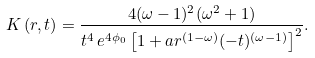<formula> <loc_0><loc_0><loc_500><loc_500>K \left ( r , t \right ) = \frac { 4 ( \omega - 1 ) ^ { 2 } ( \omega ^ { 2 } + 1 ) } { t ^ { 4 } \, e ^ { 4 \phi _ { 0 } } \left [ 1 + a r ^ { ( 1 - \omega ) } ( - t ) ^ { ( \omega - 1 ) } \right ] ^ { 2 } } .</formula> 